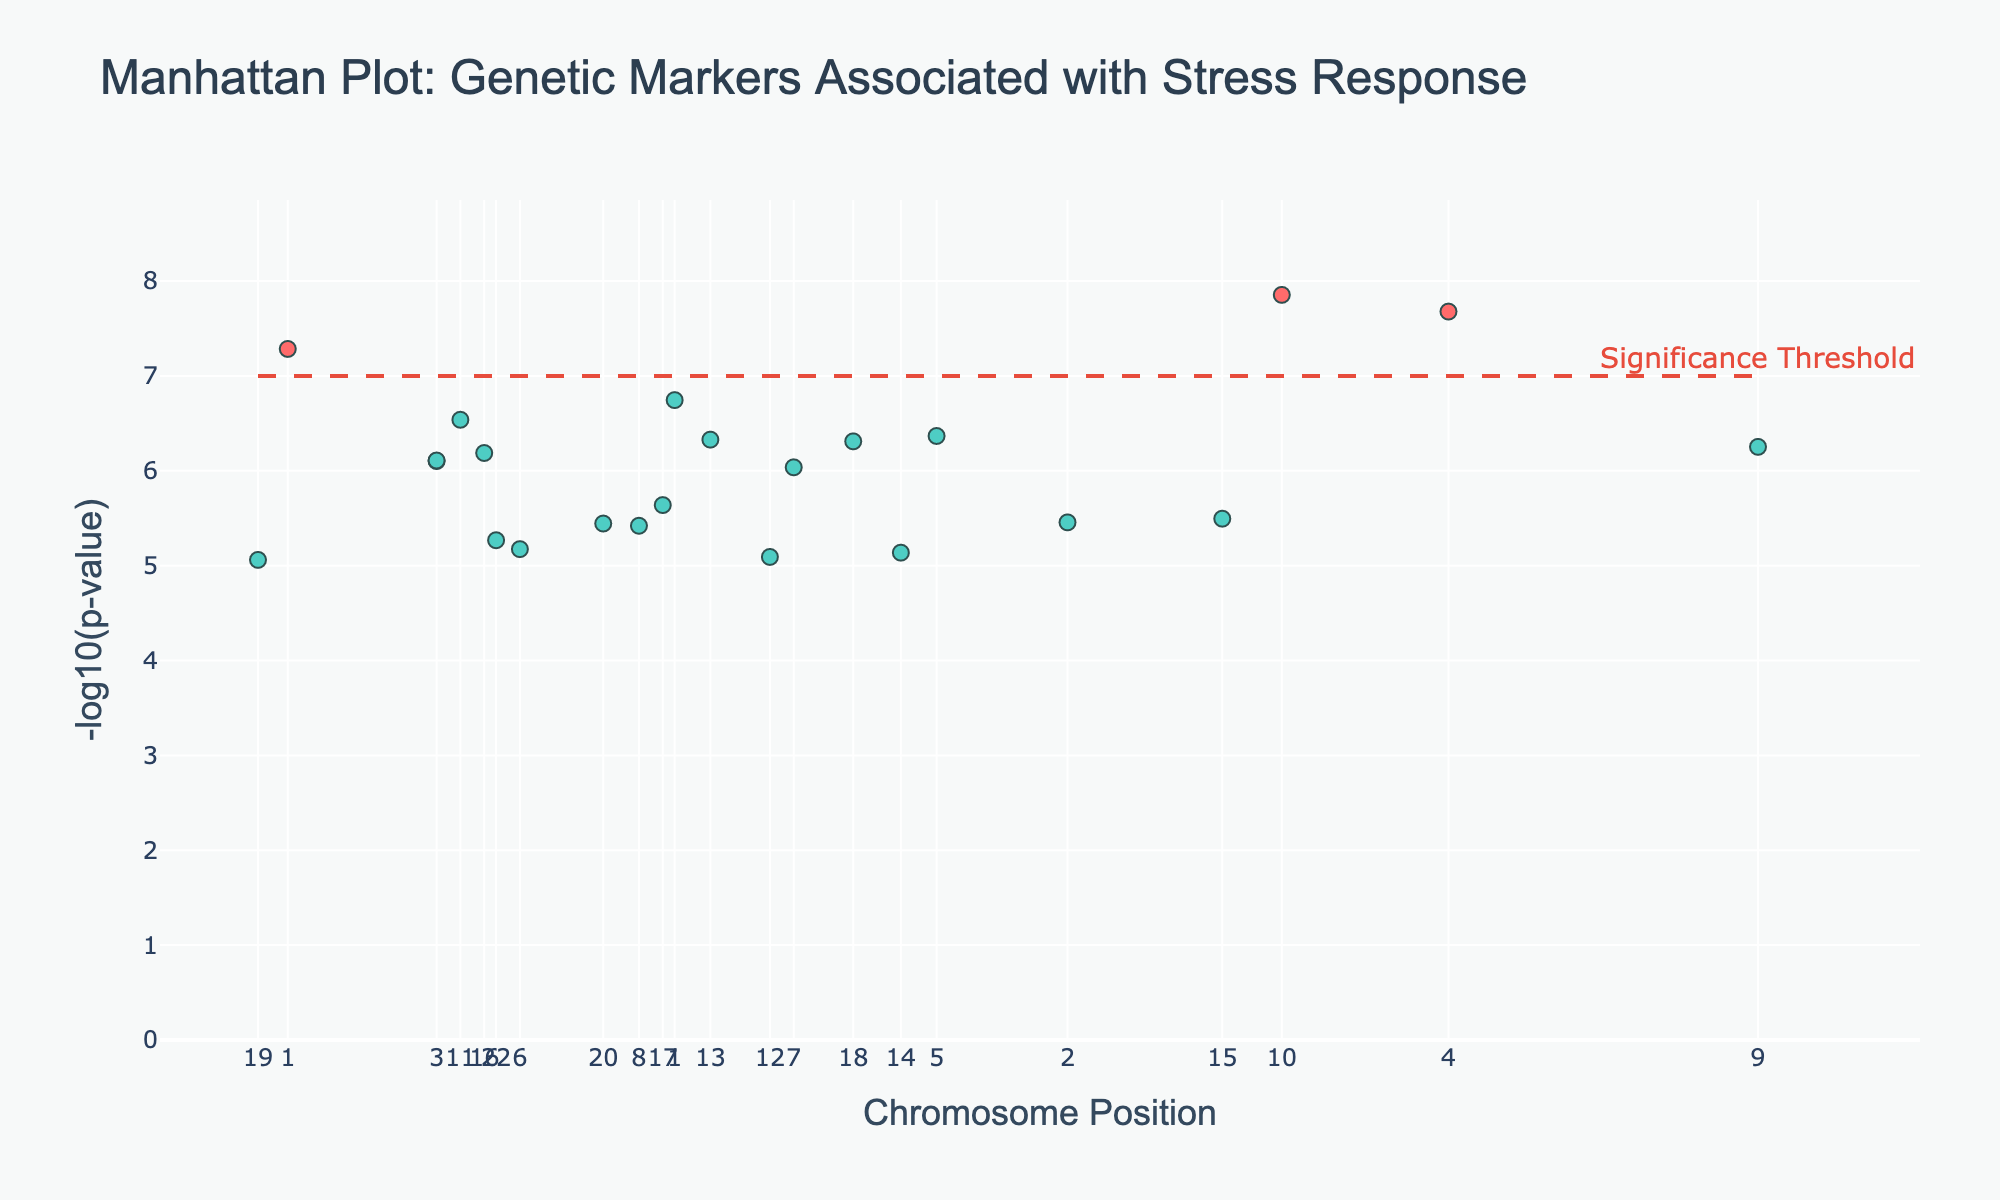What is the title of the plot? The title is the text at the top of the plot, which provides a summary of what the plot represents.
Answer: Manhattan Plot: Genetic Markers Associated with Stress Response Which gene has the lowest p-value? The gene with the lowest p-value will have the highest -log10(p) value on the y-axis. By looking at the highest point on the y-axis, we identify that it corresponds to the NR3C1 gene.
Answer: NR3C1 What does the dashed horizontal line in the plot signify? The dashed horizontal line represents the significance threshold, and it is annotated as "Significance Threshold" at a y-value around 7. This threshold helps determine which genetic markers are statistically significant.
Answer: Significance Threshold How many genes have a -log10(p) value greater than 7? By counting the number of points above the horizontal line at y = 7, we can find the genes that have a -log10(p) value greater than 7.
Answer: 3 What is the gene associated with the immune response located on chromosome 6? To find the gene associated with the immune response on chromosome 6, look at the data points labeled with genes and their positions. The gene associated with immune response on chromosome 6 is HLA-DQA1.
Answer: HLA-DQA1 Is the highest data point closer to the left or right end of the plot? The highest data point corresponds to the NR3C1 gene. By looking at the position along the x-axis, it is located near the right end of the plot.
Answer: Right end Which gene is associated with the ACTH and also has a -log10(p) value higher than 6? First, identify the gene associated with the ACTH, which is ACTH itself. Then, check if its -log10(p) value is greater than 6 by finding its corresponding point on the y-axis. The ACTH gene has a -log10(p) value higher than 6.
Answer: ACTH Between BDNF and FKBP5, which gene has a higher -log10(p) value? Compare the -log10(p) values of BDNF and FKBP5 by looking at their respective positions on the y-axis. FKBP5 has a higher -log10(p) value than BDNF.
Answer: FKBP5 